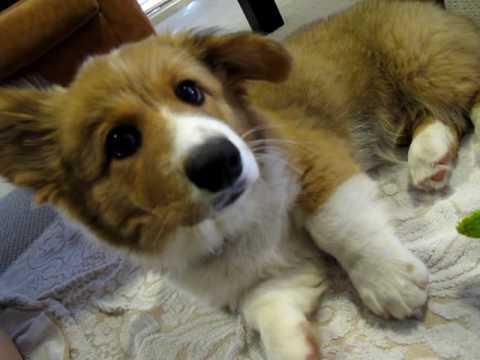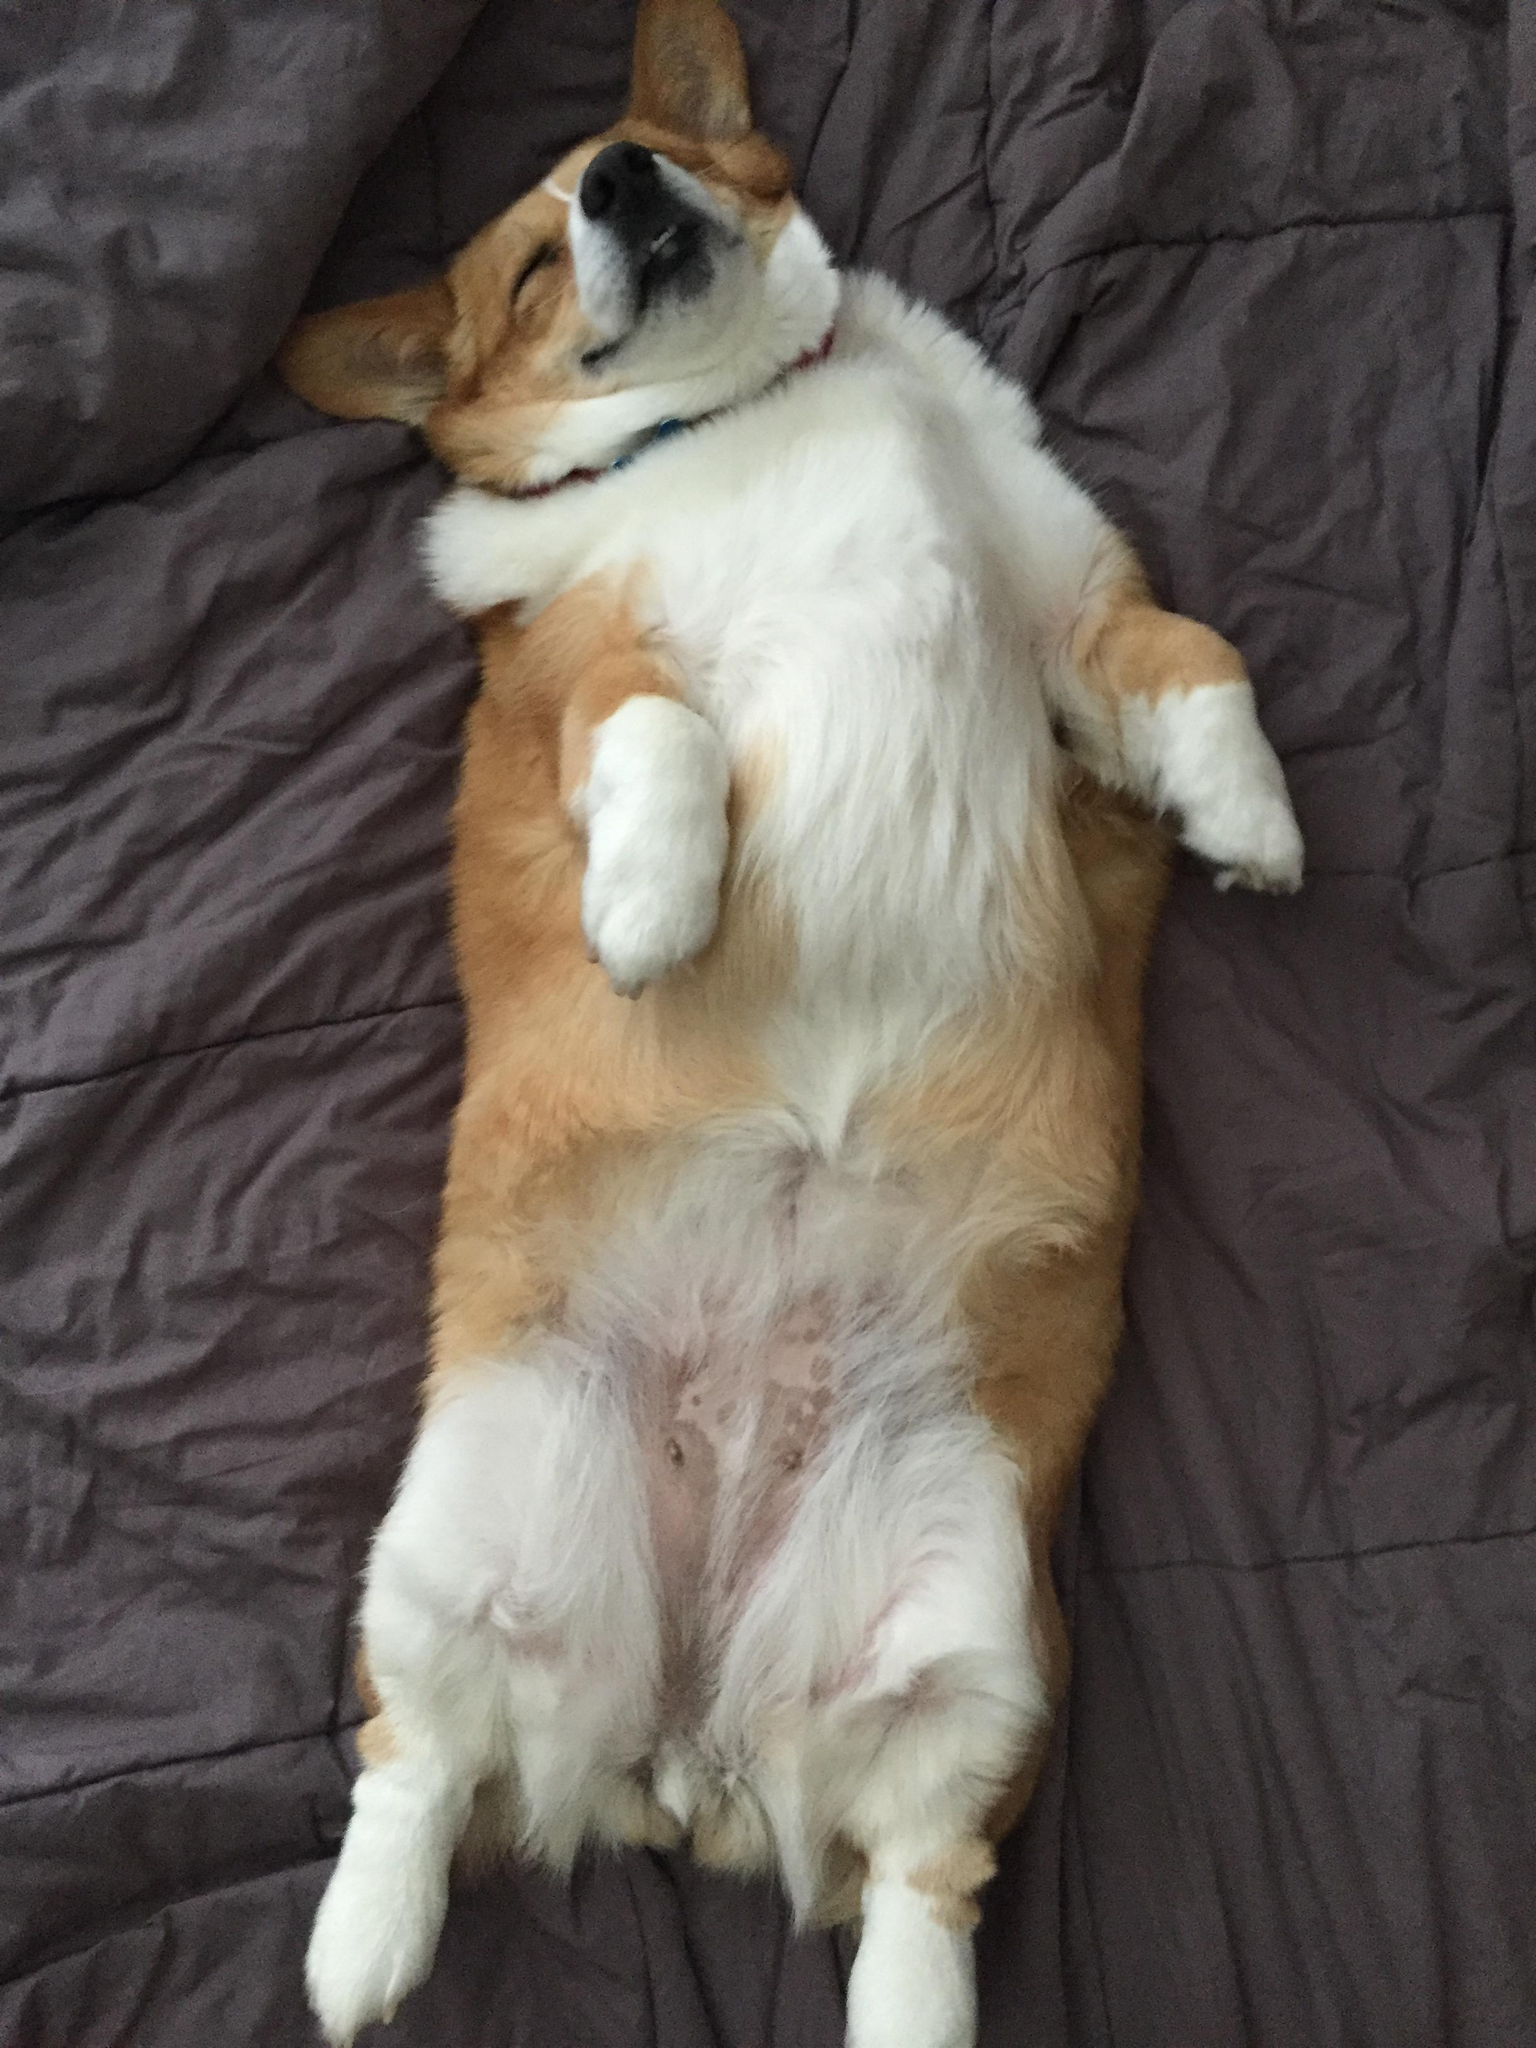The first image is the image on the left, the second image is the image on the right. Examine the images to the left and right. Is the description "There are exactly two dogs." accurate? Answer yes or no. Yes. 